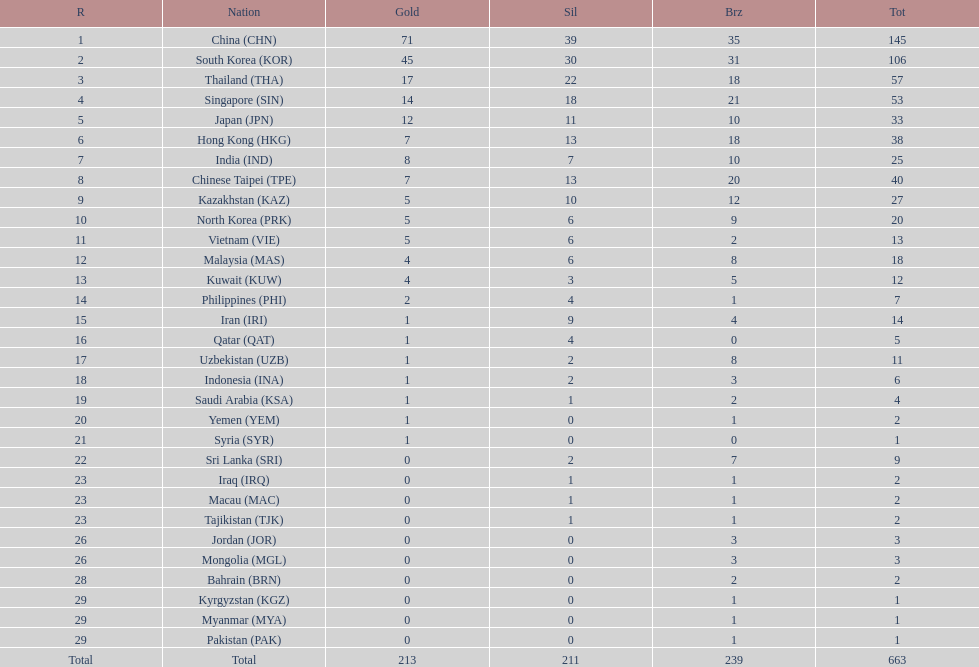Which nation has more gold medals, kuwait or india? India (IND). 